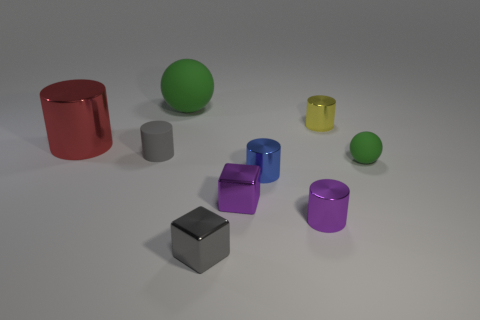Subtract all blue shiny cylinders. How many cylinders are left? 4 Subtract all gray cylinders. How many cylinders are left? 4 Subtract all spheres. How many objects are left? 7 Subtract 1 blocks. How many blocks are left? 1 Subtract all brown spheres. Subtract all yellow cylinders. How many spheres are left? 2 Subtract all large metal cylinders. Subtract all small gray matte things. How many objects are left? 7 Add 4 blue things. How many blue things are left? 5 Add 3 big blue matte blocks. How many big blue matte blocks exist? 3 Subtract 0 cyan cylinders. How many objects are left? 9 